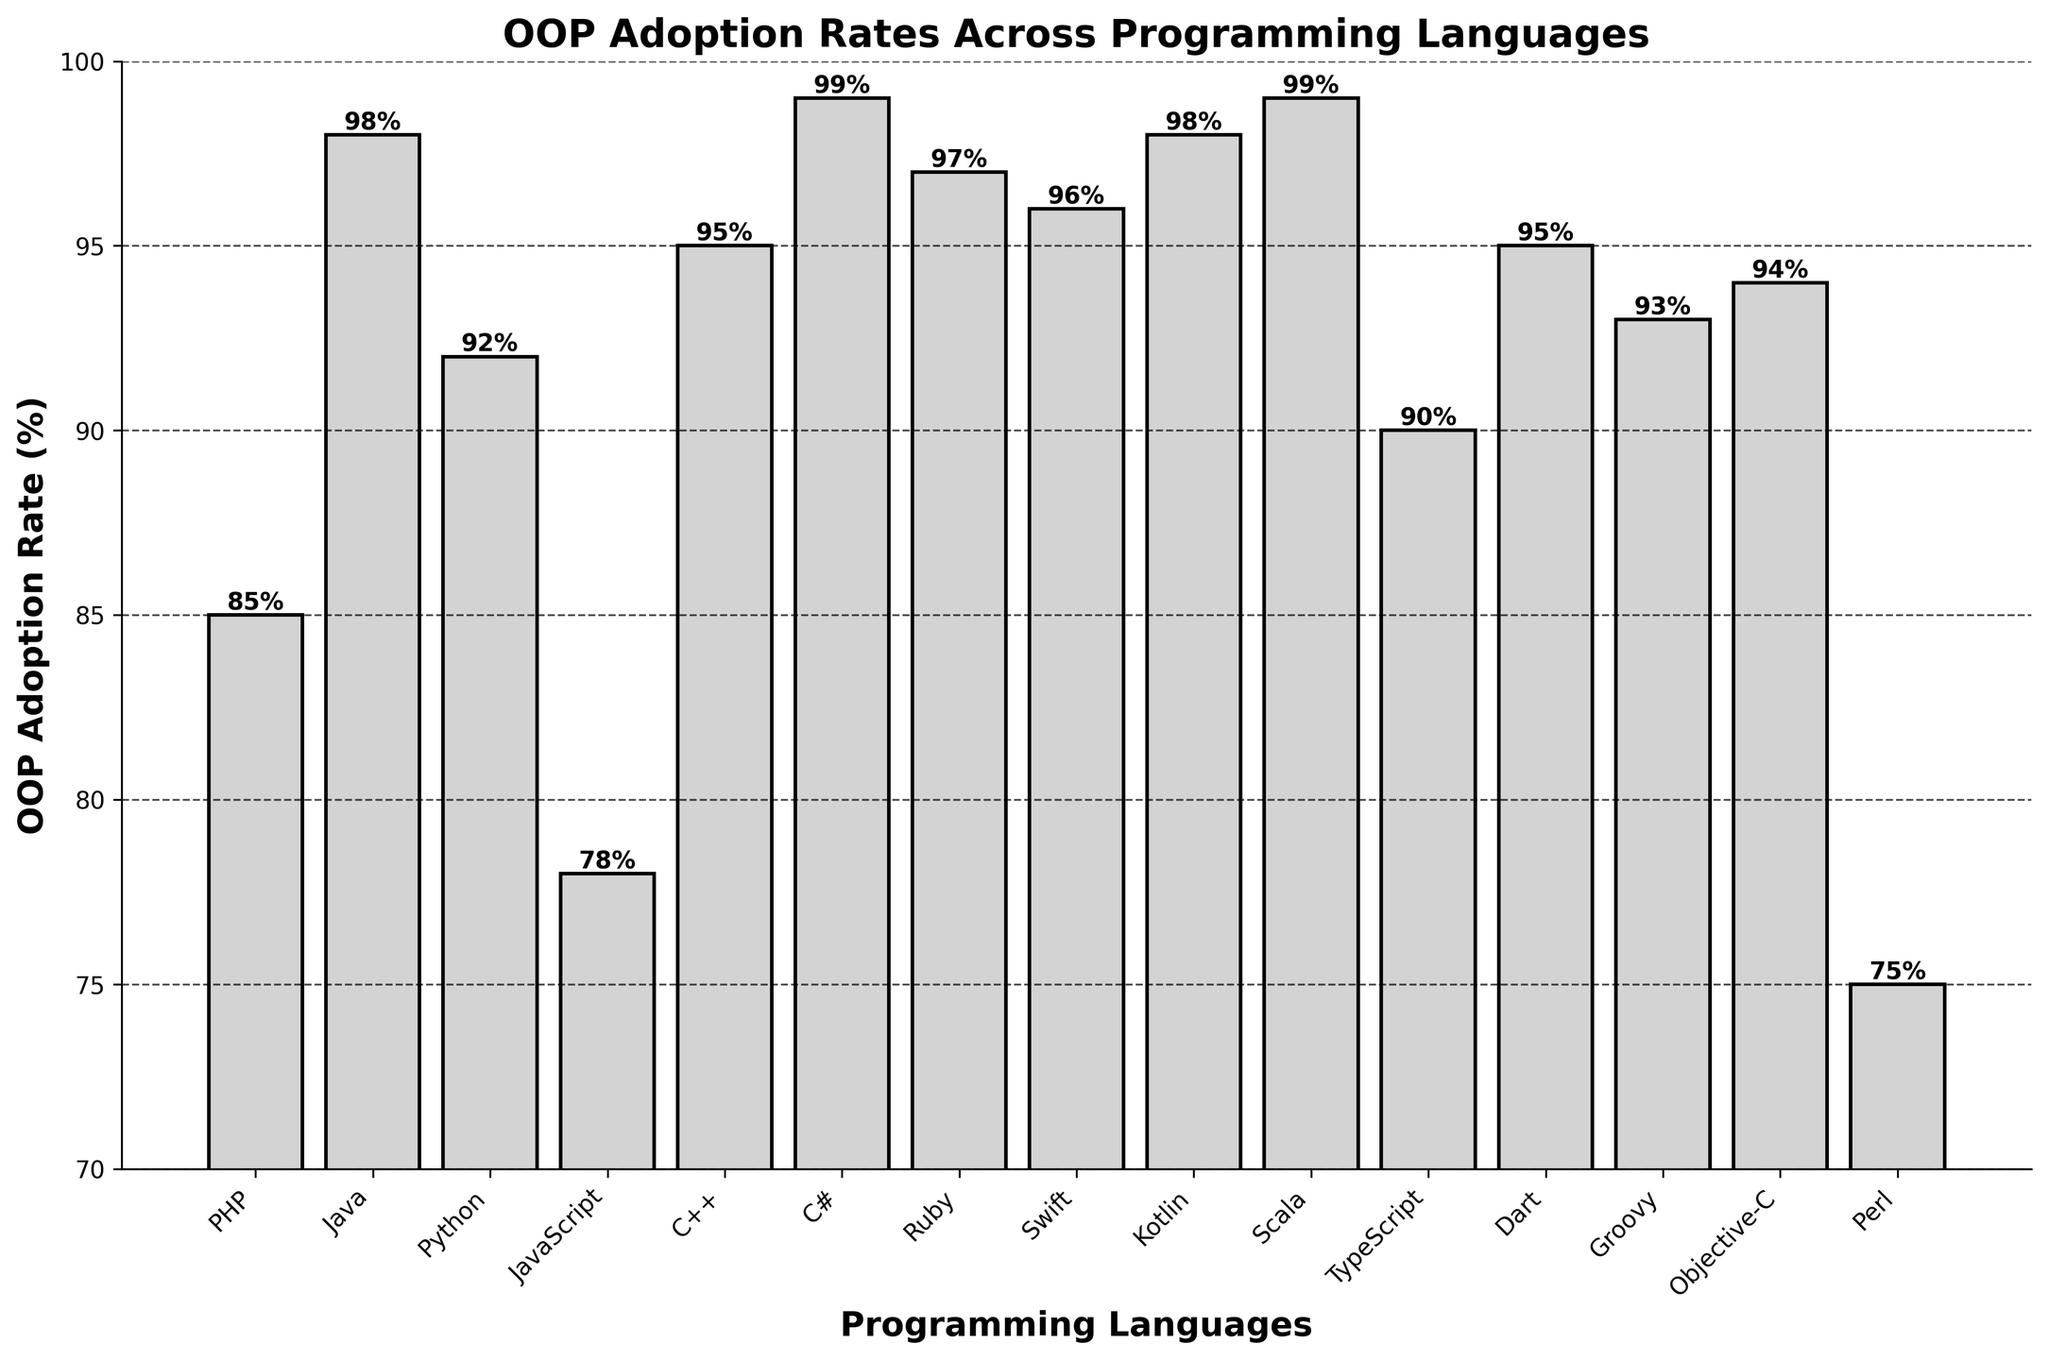Which programming language has the highest OOP adoption rate? To find the programming language with the highest OOP adoption rate, observe the bar that reaches the highest point in the chart. In this case, the C# and Scala bars both reach the highest point (99%).
Answer: C# and Scala Which programming language has the lowest OOP adoption rate? Find the bar that is the shortest in the chart. Perl's bar is the shortest with an adoption rate of 75%.
Answer: Perl Compare the adoption rates of PHP and Java. Which one is higher and by how much? Locate the bars for PHP and Java. PHP has an OOP adoption rate of 85%, and Java has an OOP adoption rate of 98%. The difference is 98% - 85% = 13%.
Answer: Java by 13% How many programming languages have an OOP adoption rate of 95% or more? Count the number of bars that reach 95% or higher. These include Java, C++, Ruby, Swift, Kotlin, Scala, Dart, Groovy, and Objective-C. Therefore, there are 9 languages.
Answer: 9 What is the average OOP adoption rate of Python, JavaScript, and TypeScript? First, add the adoption rates: Python (92%), JavaScript (78%), TypeScript (90%). The total is 92 + 78 + 90 = 260. Then, divide by the number of languages, which is 3. 260 / 3 = 86.67%.
Answer: 86.67% Which has a higher adoption rate, Ruby or Swift? Compare the heights of the Ruby and Swift bars visually. Ruby has an adoption rate of 97%, and Swift has an adoption rate of 96%. Ruby's rate is slightly higher.
Answer: Ruby What is the difference in OOP adoption rates between the top two languages with the highest adoption rates? Identify the top two languages with the highest adoption rates, which are C# (99%) and Scala (99%). The difference is 99% - 99% = 0%.
Answer: 0% What's the total OOP adoption rate sum of Dart, Kotlin, and Groovy? Add the adoption rates of Dart (95%), Kotlin (98%), and Groovy (93%). The total sum is 95 + 98 + 93 = 286.
Answer: 286 Between JavaScript and Objective-C, which language has a lower OOP adoption rate and by how much? Compare the OOP adoption rates of JavaScript (78%) and Objective-C (94%). JavaScript is lower. The difference is 94% - 78% = 16%.
Answer: JavaScript by 16% What is the median OOP adoption rate among PHP, Objective-C, and Perl? First, list the OOP adoption rates of PHP (85%), Objective-C (94%), and Perl (75%). Arrange them in order: 75%, 85%, 94%. The median value is the middle one, which is 85%.
Answer: 85% 